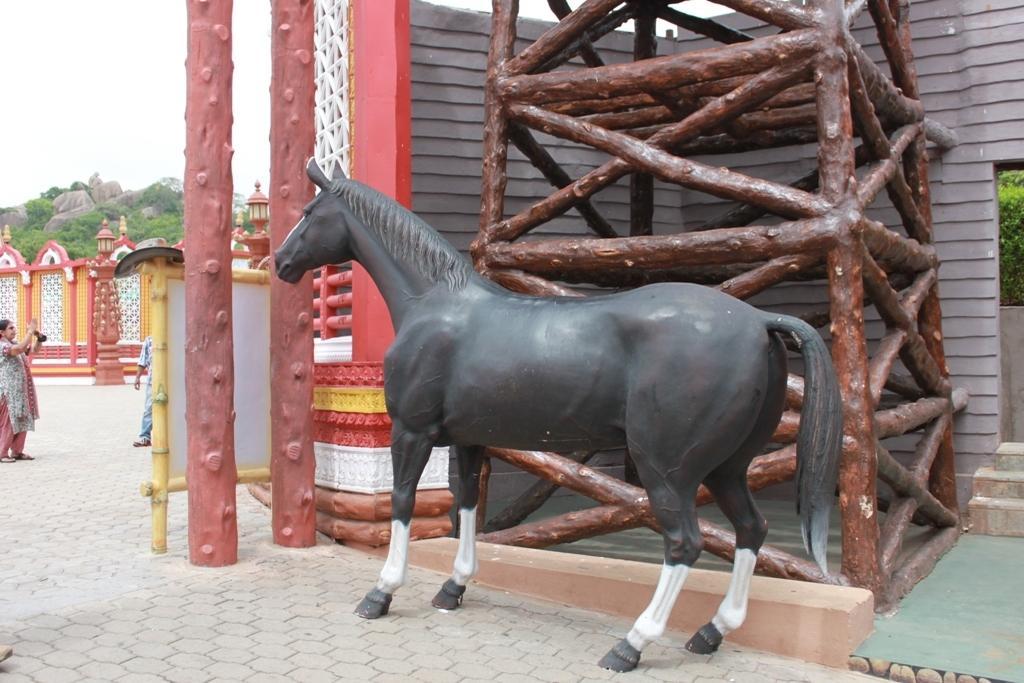In one or two sentences, can you explain what this image depicts? In this image we can see a horse statue placed on the ground. To the left side of the image we can see two persons standing on the floor and a wall In the background, we can see a group of trees, stones, poles, some wood logs and the sky. 